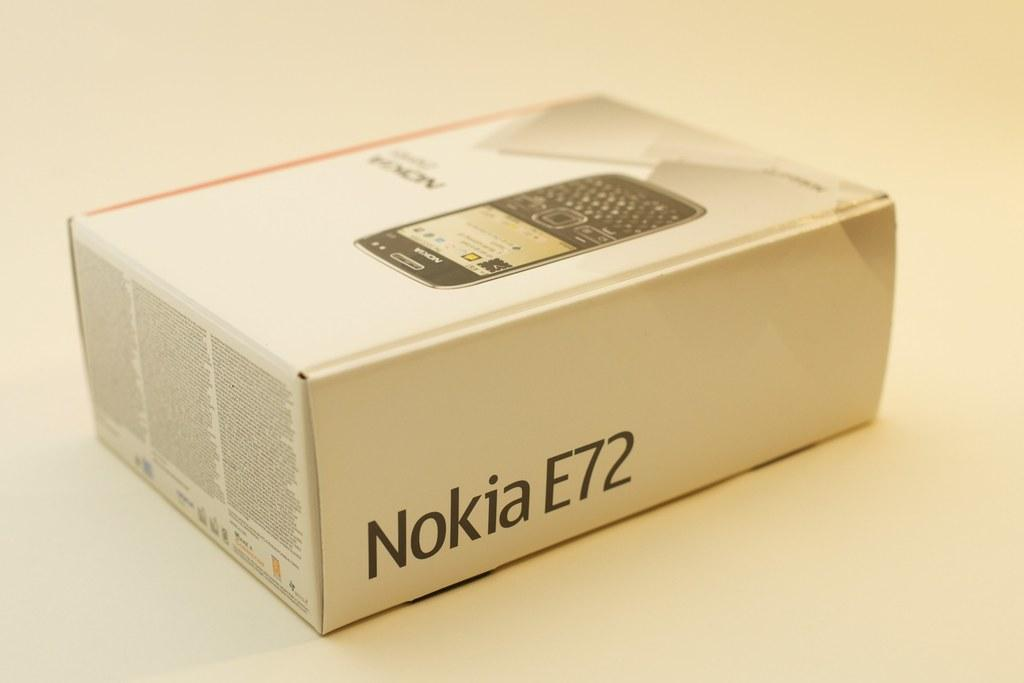Provide a one-sentence caption for the provided image. A white box for a Nokia E72 cell phone. 